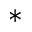Convert formula to latex. <formula><loc_0><loc_0><loc_500><loc_500>^ { * }</formula> 